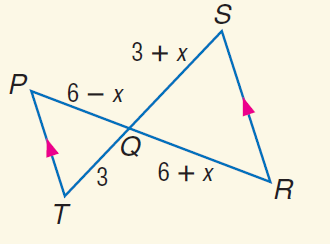Question: Find Q S.
Choices:
A. 3
B. 4
C. 6
D. 9
Answer with the letter. Answer: A Question: Find x.
Choices:
A. - 3
B. 0
C. 3
D. 6
Answer with the letter. Answer: B 